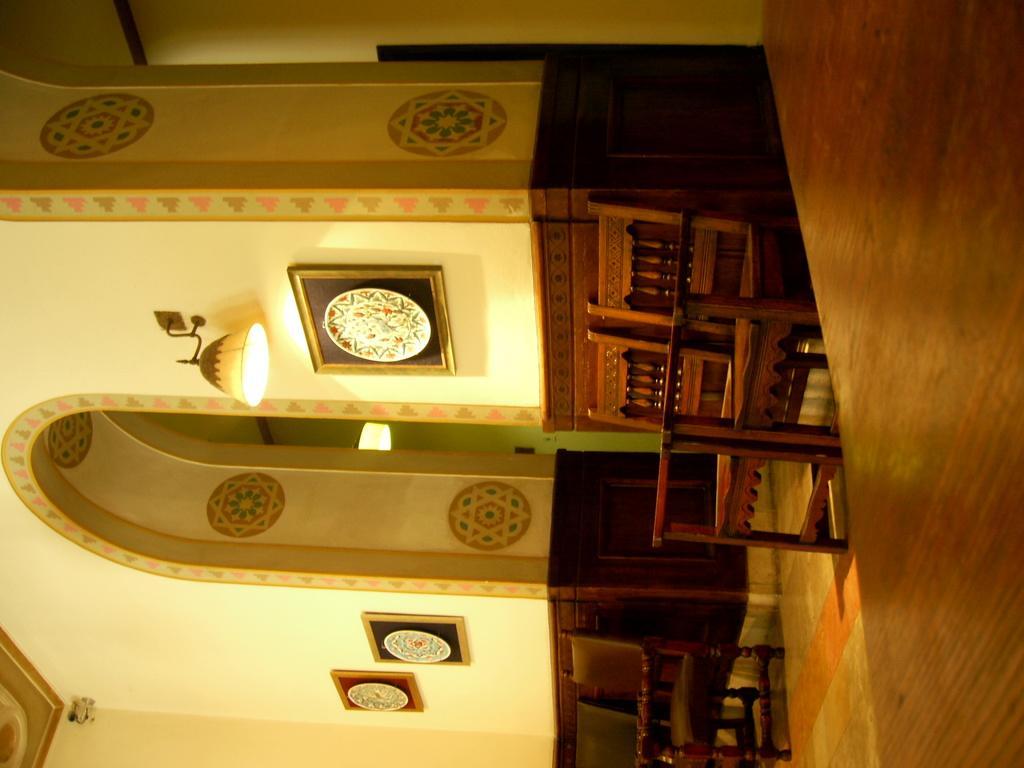Describe this image in one or two sentences. This is inside a building. On the right side there are chairs. Also there are arches. On the wall there some images. Also on the wall there is light and photo frames. 